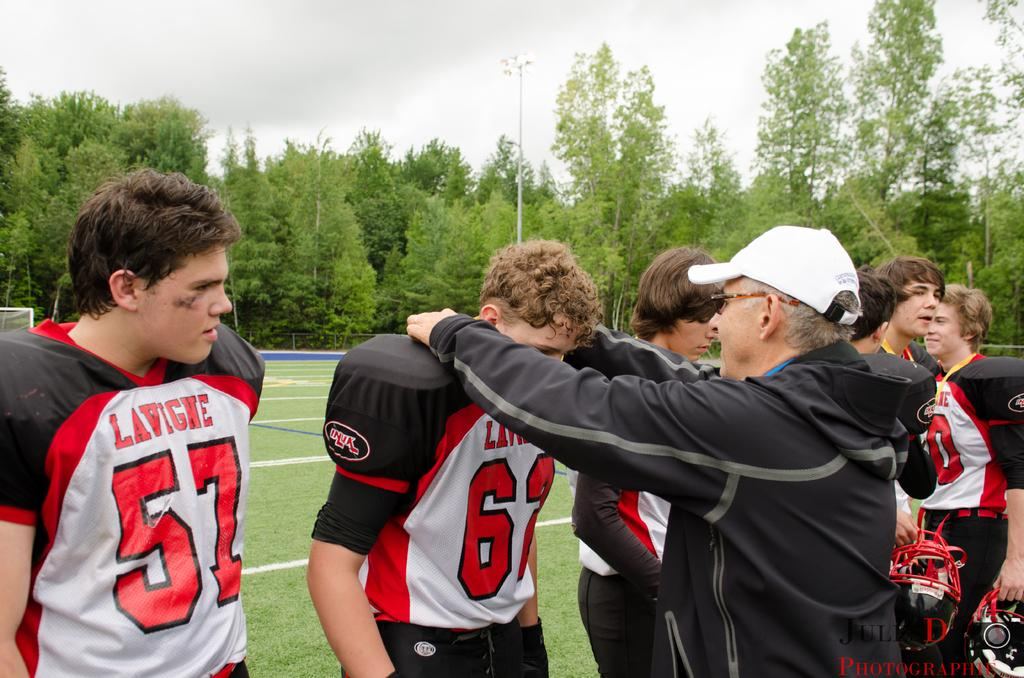<image>
Summarize the visual content of the image. a man that is playing football and is wearing 57 